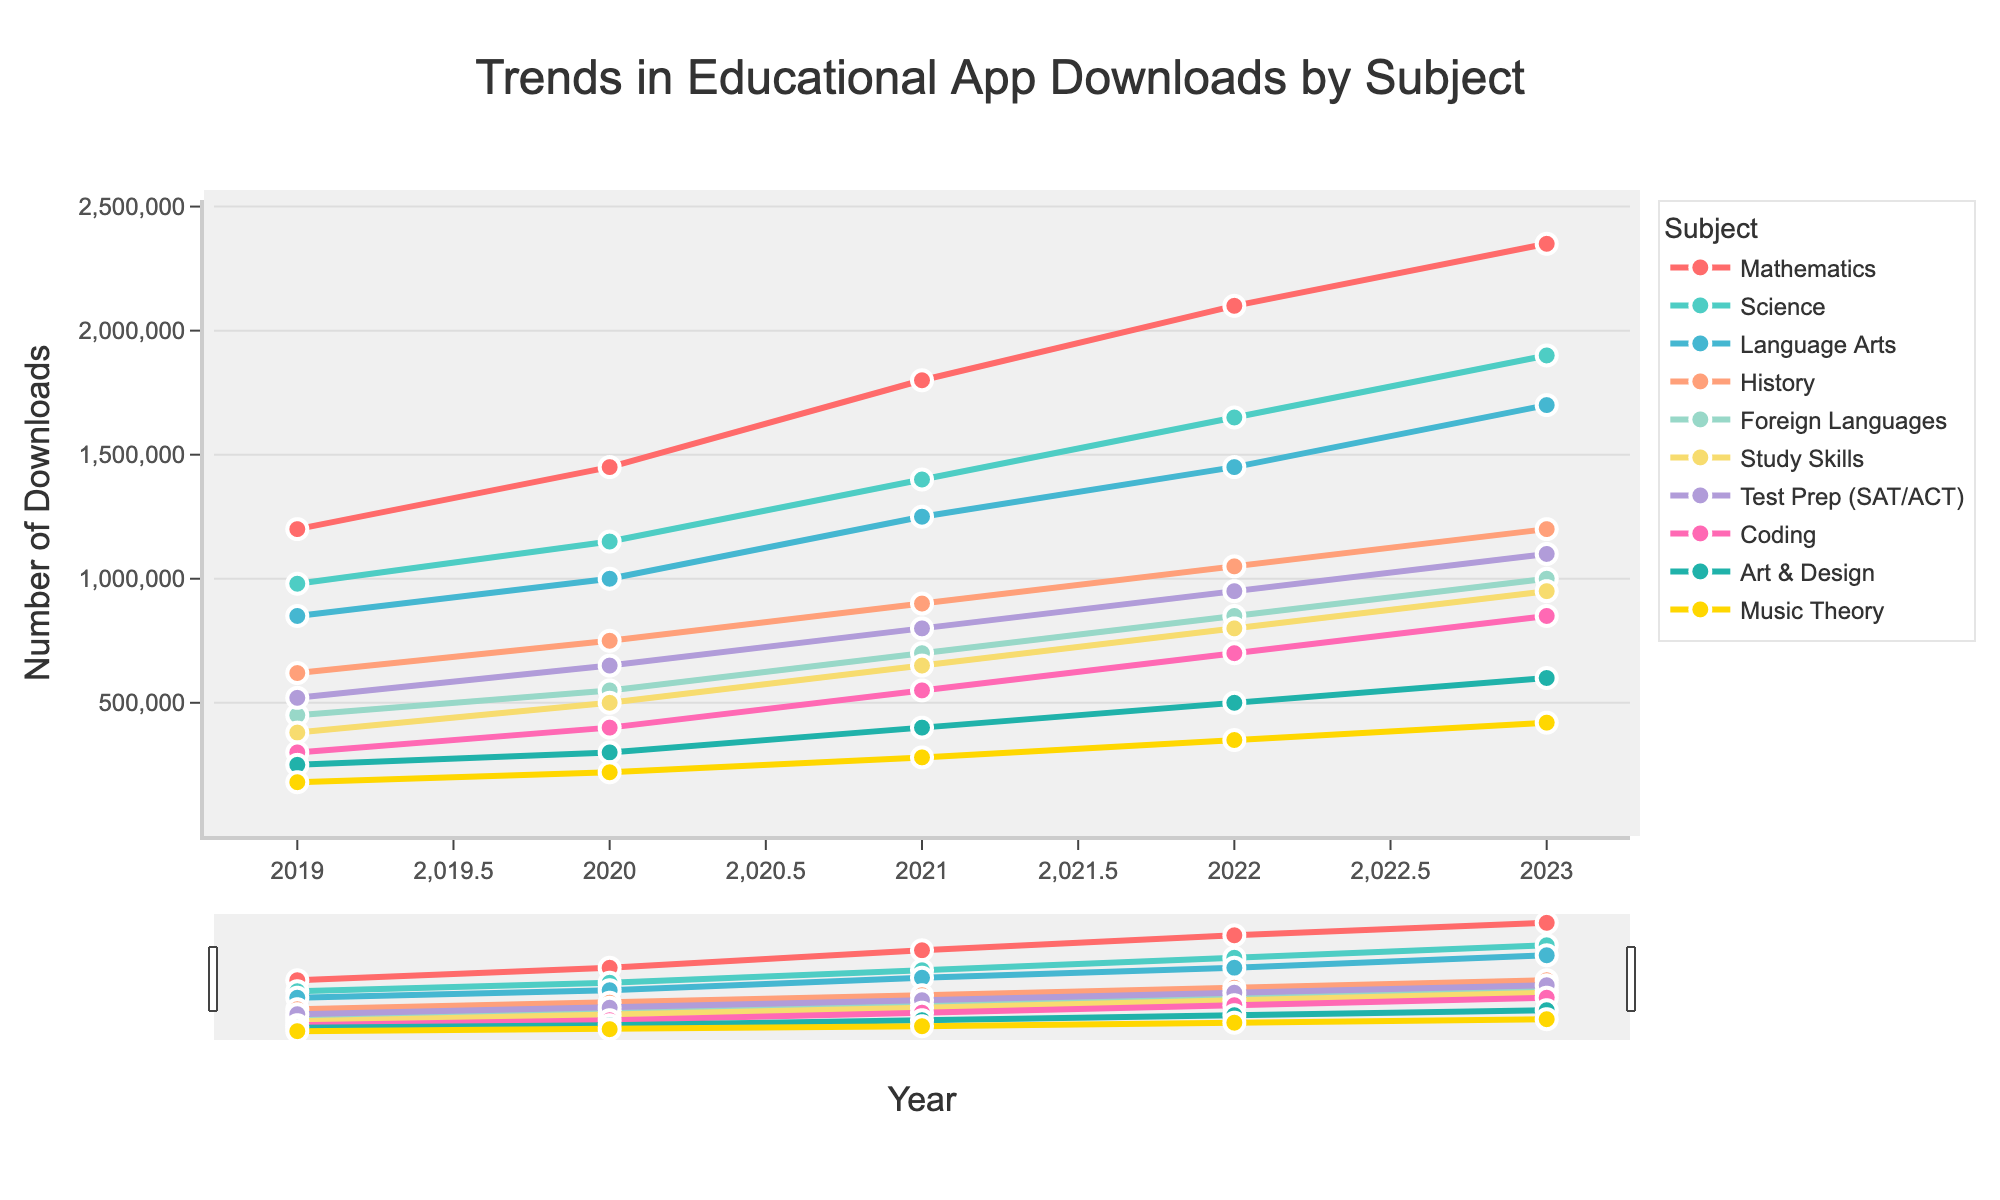What subject showed the highest increase in app downloads between 2019 and 2023? To find the subject with the highest increase, subtract the 2019 downloads from the 2023 downloads for each subject. Mathematics increased from 1,200,000 to 2,350,000 (1,150,000 increase); Science from 980,000 to 1,900,000 (920,000 increase); and so on. The highest increase is in Mathematics with 1,150,000.
Answer: Mathematics Which subject had more downloads in 2023: Language Arts or Foreign Languages? Look at the 2023 data for both subjects. Language Arts had 1,700,000 downloads, while Foreign Languages had 1,000,000. Since 1,700,000 is greater than 1,000,000, Language Arts had more downloads.
Answer: Language Arts What's the total number of downloads across all subjects in 2022? Sum the 2022 downloads for each subject: Mathematics (2,100,000), Science (1,650,000), Language Arts (1,450,000), History (1,050,000), Foreign Languages (850,000), Study Skills (800,000), Test Prep (950,000), Coding (700,000), Art & Design (500,000), and Music Theory (350,000). The total is 10,400,000.
Answer: 10,400,000 Which subject experienced the smallest growth in app downloads from 2019 to 2023? Calculate the growth by subtracting the 2019 downloads from the 2023 downloads. For instance, Music Theory grew from 180,000 to 420,000, which is an increase of 240,000. The subject with the smallest growth is Music Theory with an increase of 240,000.
Answer: Music Theory Between 2021 and 2022, did the number of downloads for Study Skills increase more or less than the number of downloads for Coding? Look at the difference between 2021 and 2022 for both subjects. Study Skills increased from 650,000 to 800,000 (150,000 increase), while Coding increased from 550,000 to 700,000 (150,000 increase). Both subjects had the same increase.
Answer: Same 